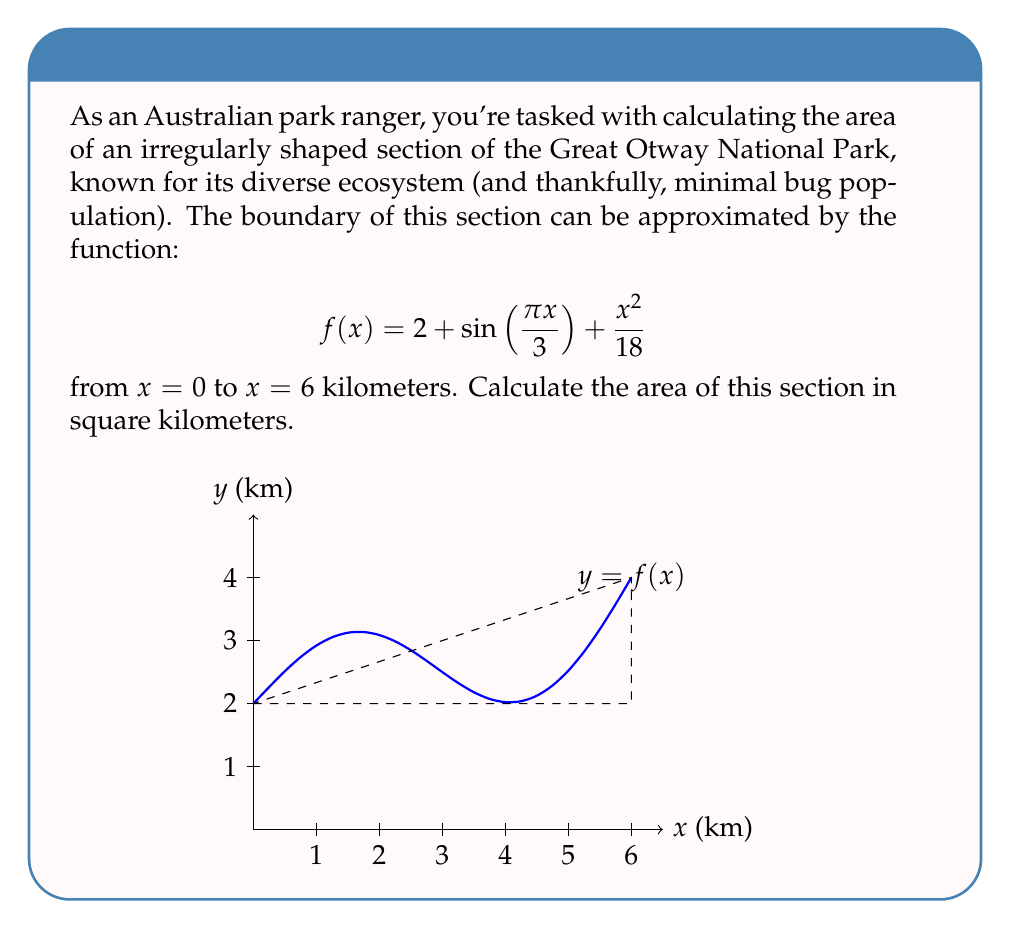Solve this math problem. To calculate the area of this irregular-shaped section, we need to use definite integration. The area under a curve $f(x)$ from $a$ to $b$ is given by:

$$\text{Area} = \int_a^b f(x) dx$$

In this case, we have:
$$f(x) = 2 + \sin(\frac{\pi x}{3}) + \frac{x^2}{18}$$
$$a = 0, b = 6$$

Let's integrate the function:

1) Integrate the constant term:
   $$\int 2 dx = 2x$$

2) Integrate the sine term:
   $$\int \sin(\frac{\pi x}{3}) dx = -\frac{3}{\pi} \cos(\frac{\pi x}{3})$$

3) Integrate the quadratic term:
   $$\int \frac{x^2}{18} dx = \frac{x^3}{54}$$

Combining these results:

$$\int f(x) dx = 2x - \frac{3}{\pi} \cos(\frac{\pi x}{3}) + \frac{x^3}{54} + C$$

Now, we apply the limits:

$$\text{Area} = \left[2x - \frac{3}{\pi} \cos(\frac{\pi x}{3}) + \frac{x^3}{54}\right]_0^6$$

$$= \left(12 - \frac{3}{\pi} \cos(2\pi) + \frac{216}{54}\right) - \left(0 - \frac{3}{\pi} \cos(0) + 0\right)$$

$$= 12 - \frac{3}{\pi} + 4 + \frac{3}{\pi}$$

$$= 16$$

Therefore, the area of this section of the Great Otway National Park is 16 square kilometers.
Answer: 16 km² 